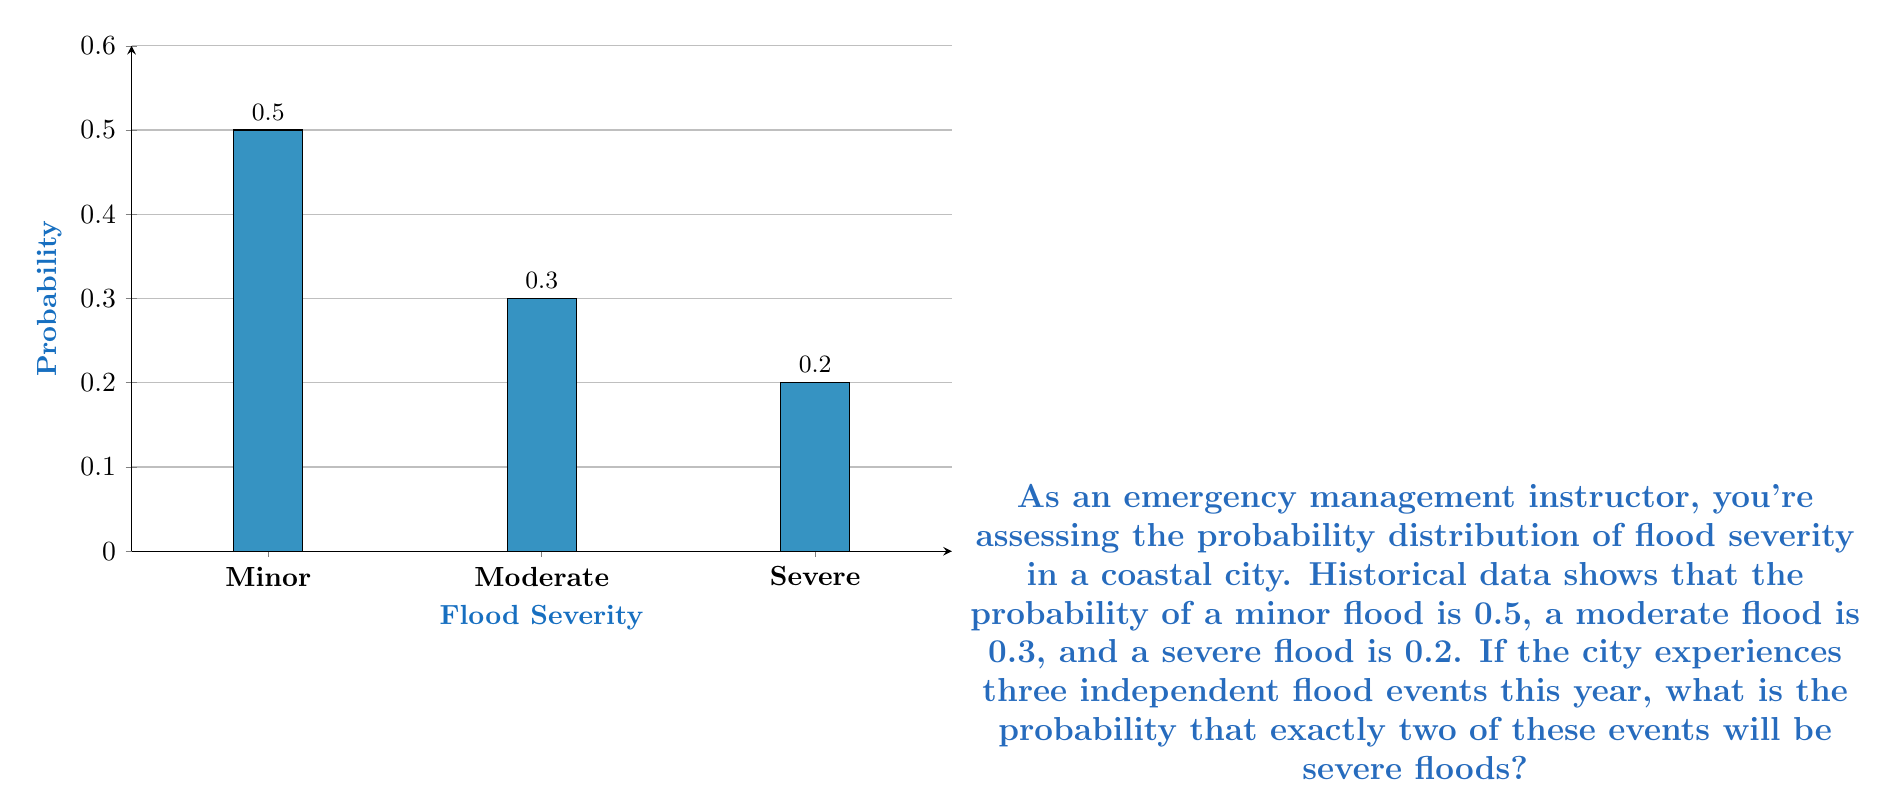Help me with this question. To solve this problem, we'll use the binomial probability distribution. The binomial distribution is appropriate when we have a fixed number of independent trials, each with the same probability of success.

Let's break it down step-by-step:

1) We have 3 independent flood events (n = 3).
2) We want exactly 2 severe floods (k = 2).
3) The probability of a severe flood is 0.2 (p = 0.2).

The binomial probability formula is:

$$ P(X = k) = \binom{n}{k} p^k (1-p)^{n-k} $$

Where:
- $\binom{n}{k}$ is the binomial coefficient, calculated as $\frac{n!}{k!(n-k)!}$
- $p$ is the probability of success on each trial
- $n$ is the number of trials
- $k$ is the number of successes

Let's plug in our values:

$$ P(X = 2) = \binom{3}{2} (0.2)^2 (1-0.2)^{3-2} $$

Now, let's calculate each part:

1) $\binom{3}{2} = \frac{3!}{2!(3-2)!} = \frac{3 \cdot 2 \cdot 1}{(2 \cdot 1)(1)} = 3$

2) $(0.2)^2 = 0.04$

3) $(1-0.2)^{3-2} = 0.8^1 = 0.8$

Putting it all together:

$$ P(X = 2) = 3 \cdot 0.04 \cdot 0.8 = 0.096 $$

Therefore, the probability of exactly two severe floods out of three flood events is 0.096 or 9.6%.
Answer: 0.096 